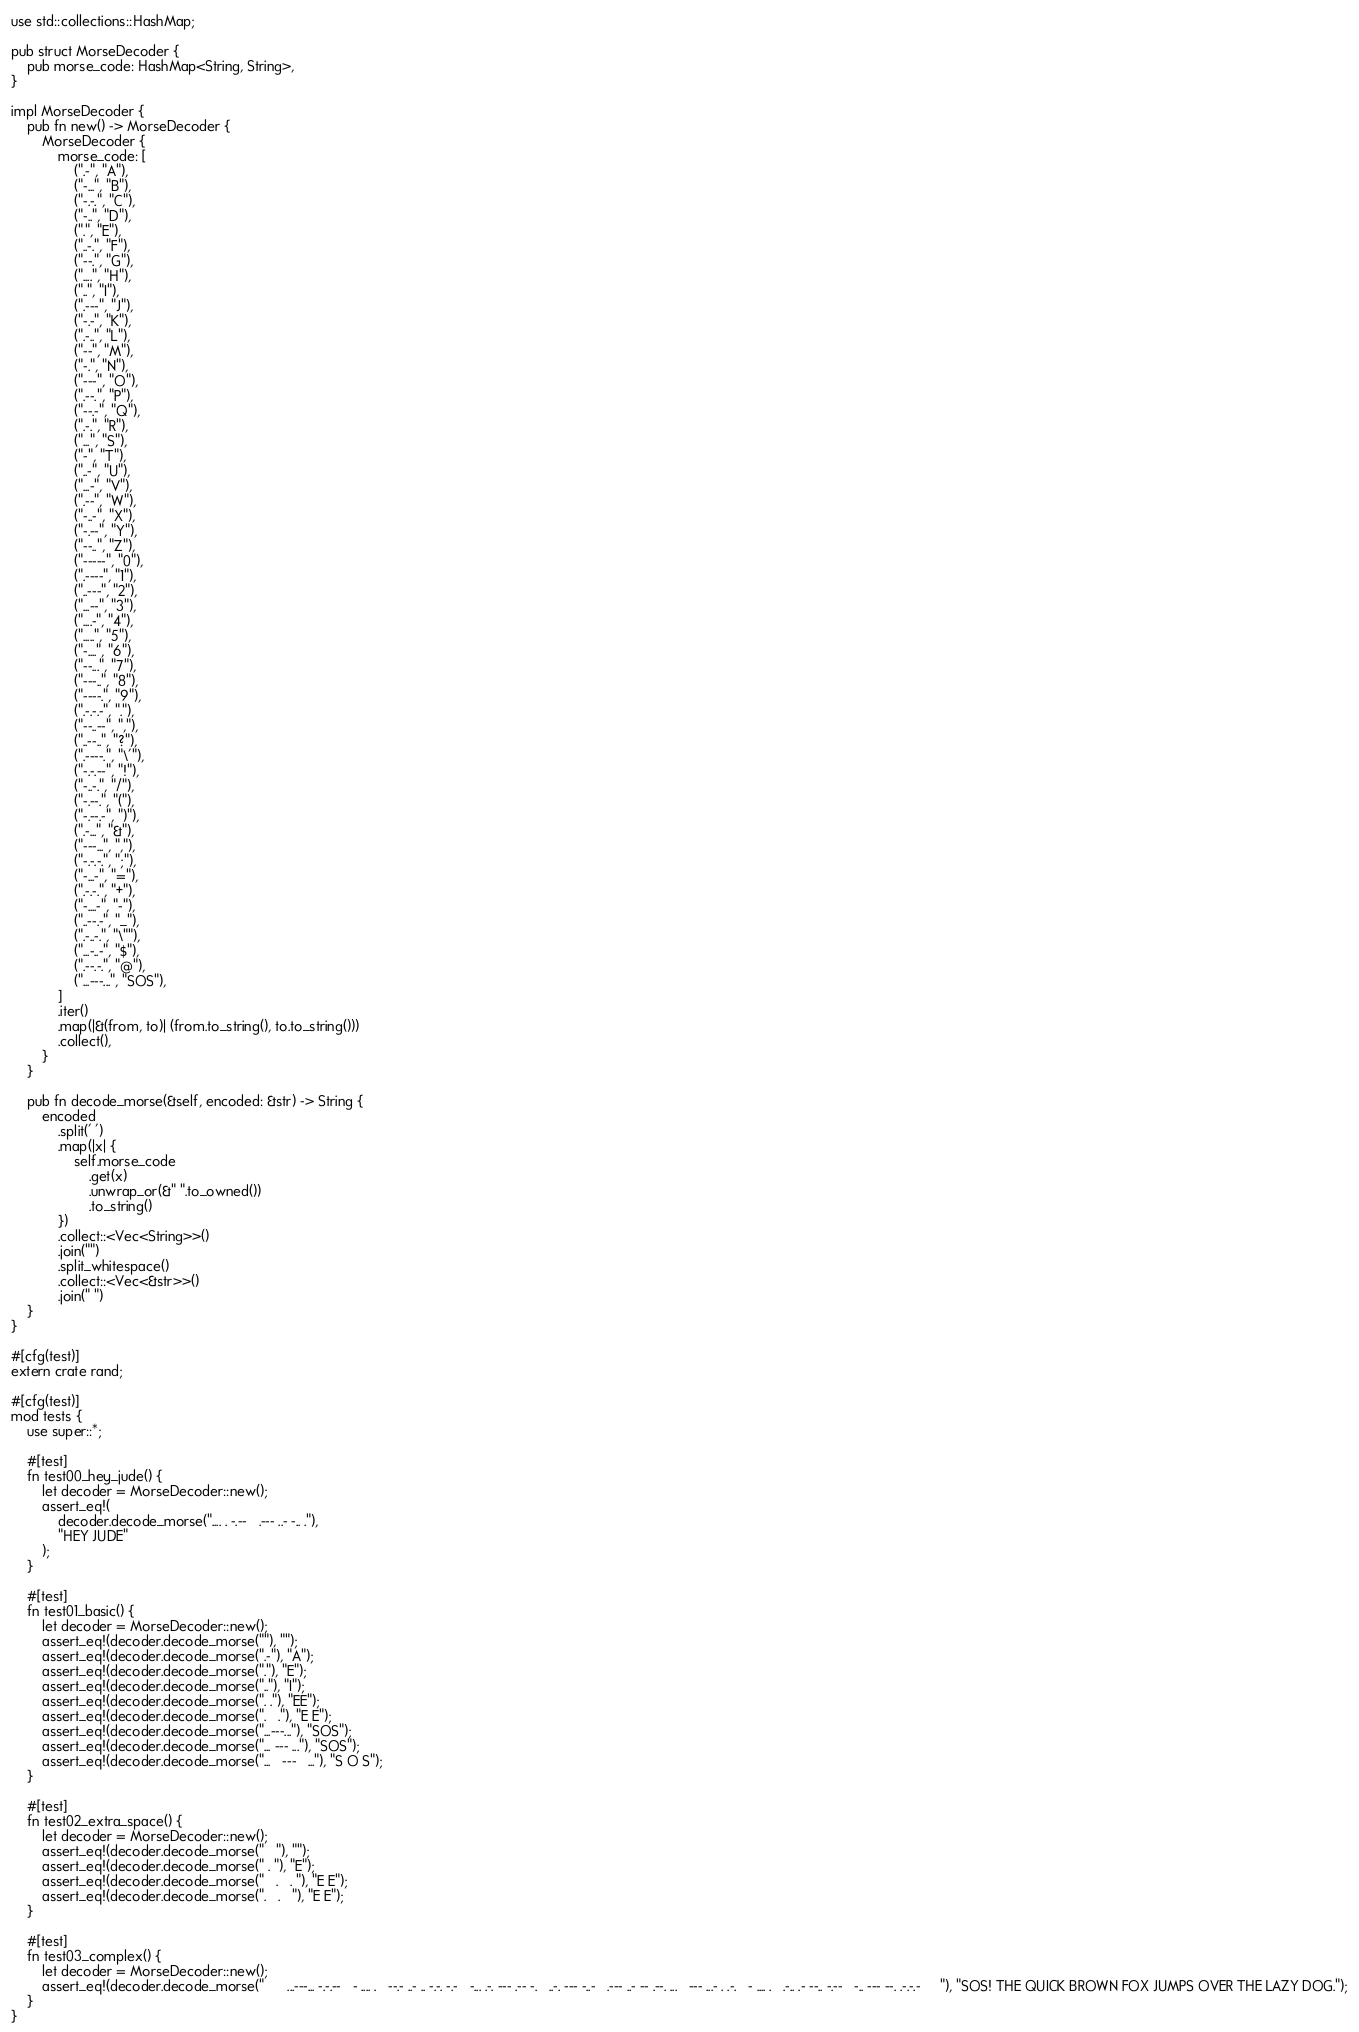Convert code to text. <code><loc_0><loc_0><loc_500><loc_500><_Rust_>use std::collections::HashMap;

pub struct MorseDecoder {
    pub morse_code: HashMap<String, String>,
}

impl MorseDecoder {
    pub fn new() -> MorseDecoder {
        MorseDecoder {
            morse_code: [
                (".-", "A"),
                ("-...", "B"),
                ("-.-.", "C"),
                ("-..", "D"),
                (".", "E"),
                ("..-.", "F"),
                ("--.", "G"),
                ("....", "H"),
                ("..", "I"),
                (".---", "J"),
                ("-.-", "K"),
                (".-..", "L"),
                ("--", "M"),
                ("-.", "N"),
                ("---", "O"),
                (".--.", "P"),
                ("--.-", "Q"),
                (".-.", "R"),
                ("...", "S"),
                ("-", "T"),
                ("..-", "U"),
                ("...-", "V"),
                (".--", "W"),
                ("-..-", "X"),
                ("-.--", "Y"),
                ("--..", "Z"),
                ("-----", "0"),
                (".----", "1"),
                ("..---", "2"),
                ("...--", "3"),
                ("....-", "4"),
                (".....", "5"),
                ("-....", "6"),
                ("--...", "7"),
                ("---..", "8"),
                ("----.", "9"),
                (".-.-.-", "."),
                ("--..--", ","),
                ("..--..", "?"),
                (".----.", "\'"),
                ("-.-.--", "!"),
                ("-..-.", "/"),
                ("-.--.", "("),
                ("-.--.-", ")"),
                (".-...", "&"),
                ("---...", ","),
                ("-.-.-.", ";"),
                ("-...-", "="),
                (".-.-.", "+"),
                ("-....-", "-"),
                ("..--.-", "_"),
                (".-..-.", "\""),
                ("...-..-", "$"),
                (".--.-.", "@"),
                ("...---...", "SOS"),
            ]
            .iter()
            .map(|&(from, to)| (from.to_string(), to.to_string()))
            .collect(),
        }
    }

    pub fn decode_morse(&self, encoded: &str) -> String {
        encoded
            .split(' ')
            .map(|x| {
                self.morse_code
                    .get(x)
                    .unwrap_or(&" ".to_owned())
                    .to_string()
            })
            .collect::<Vec<String>>()
            .join("")
            .split_whitespace()
            .collect::<Vec<&str>>()
            .join(" ")
    }
}

#[cfg(test)]
extern crate rand;

#[cfg(test)]
mod tests {
    use super::*;

    #[test]
    fn test00_hey_jude() {
        let decoder = MorseDecoder::new();
        assert_eq!(
            decoder.decode_morse(".... . -.--   .--- ..- -.. ."),
            "HEY JUDE"
        );
    }

    #[test]
    fn test01_basic() {
        let decoder = MorseDecoder::new();
        assert_eq!(decoder.decode_morse(""), "");
        assert_eq!(decoder.decode_morse(".-"), "A");
        assert_eq!(decoder.decode_morse("."), "E");
        assert_eq!(decoder.decode_morse(".."), "I");
        assert_eq!(decoder.decode_morse(". ."), "EE");
        assert_eq!(decoder.decode_morse(".   ."), "E E");
        assert_eq!(decoder.decode_morse("...---..."), "SOS");
        assert_eq!(decoder.decode_morse("... --- ..."), "SOS");
        assert_eq!(decoder.decode_morse("...   ---   ..."), "S O S");
    }

    #[test]
    fn test02_extra_space() {
        let decoder = MorseDecoder::new();
        assert_eq!(decoder.decode_morse("   "), "");
        assert_eq!(decoder.decode_morse(" . "), "E");
        assert_eq!(decoder.decode_morse("   .   . "), "E E");
        assert_eq!(decoder.decode_morse(".   .   "), "E E");
    }

    #[test]
    fn test03_complex() {
        let decoder = MorseDecoder::new();
        assert_eq!(decoder.decode_morse("      ...---... -.-.--   - .... .   --.- ..- .. -.-. -.-   -... .-. --- .-- -.   ..-. --- -..-   .--- ..- -- .--. ...   --- ...- . .-.   - .... .   .-.. .- --.. -.--   -.. --- --. .-.-.-     "), "SOS! THE QUICK BROWN FOX JUMPS OVER THE LAZY DOG.");
    }
}
</code> 